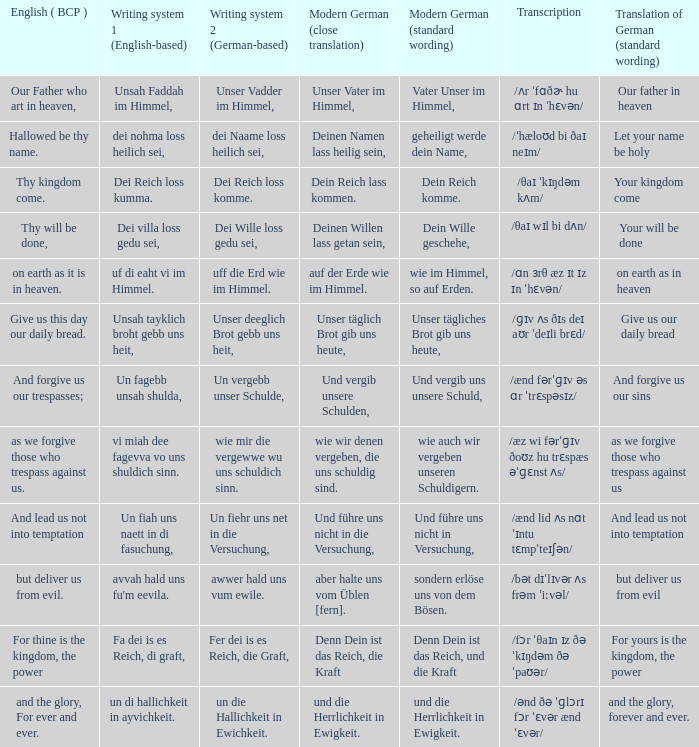What is the english (bcp) phrase "for thine is the kingdom, the power" in modern german with standard wording? Denn Dein ist das Reich, und die Kraft. 